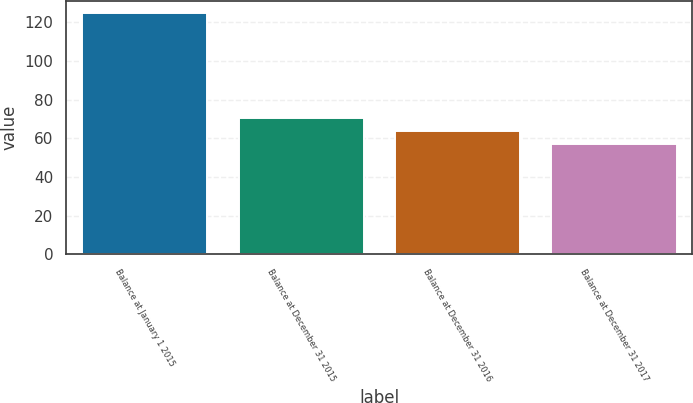Convert chart to OTSL. <chart><loc_0><loc_0><loc_500><loc_500><bar_chart><fcel>Balance at January 1 2015<fcel>Balance at December 31 2015<fcel>Balance at December 31 2016<fcel>Balance at December 31 2017<nl><fcel>125<fcel>70.6<fcel>63.8<fcel>57<nl></chart> 